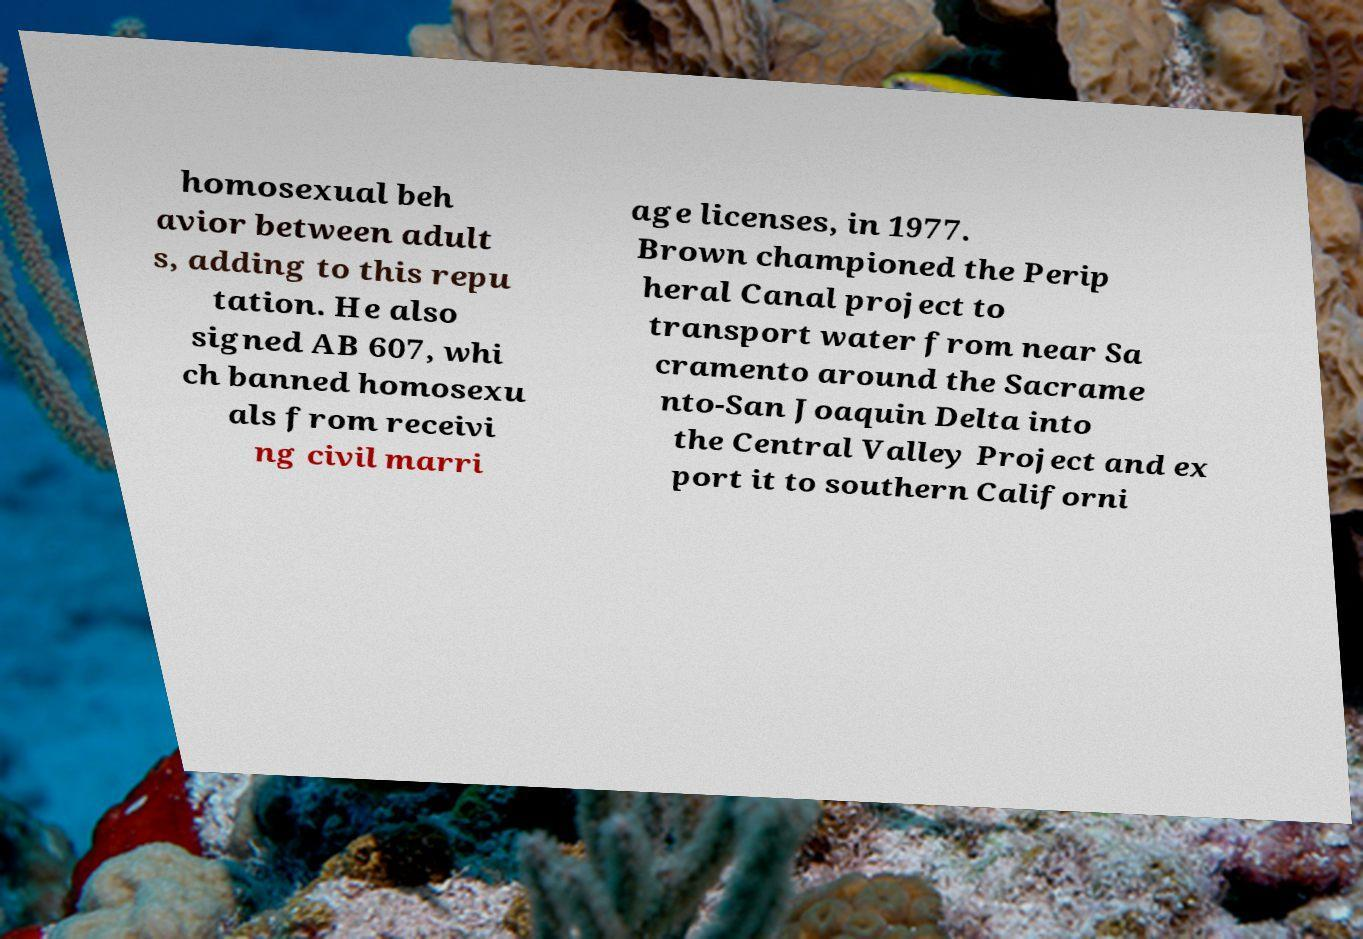Please identify and transcribe the text found in this image. homosexual beh avior between adult s, adding to this repu tation. He also signed AB 607, whi ch banned homosexu als from receivi ng civil marri age licenses, in 1977. Brown championed the Perip heral Canal project to transport water from near Sa cramento around the Sacrame nto-San Joaquin Delta into the Central Valley Project and ex port it to southern Californi 